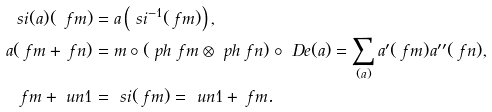Convert formula to latex. <formula><loc_0><loc_0><loc_500><loc_500>\ s i ( a ) ( \ f m ) & = a \left ( \ s i ^ { - 1 } ( \ f m ) \right ) , \\ a ( \ f m + \ f n ) & = m \circ ( \ p h _ { \ } f m \otimes \ p h _ { \ } f n ) \circ \ D e ( a ) = \sum _ { ( a ) } a ^ { \prime } ( \ f m ) a ^ { \prime \prime } ( \ f n ) , \\ \ f m + \ u n { 1 } & = \ s i ( \ f m ) = \ u n { 1 } + \ f m .</formula> 